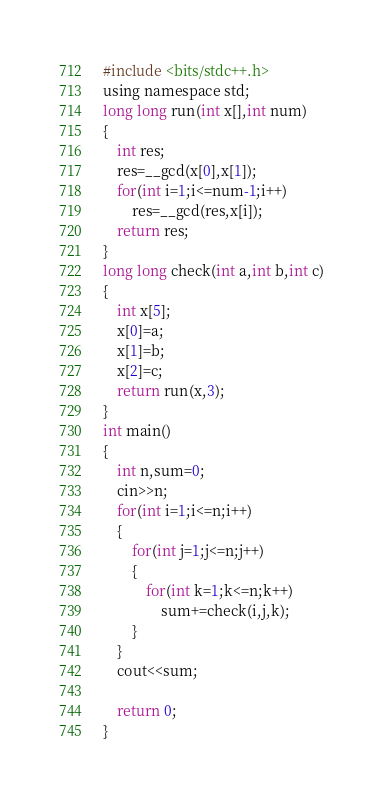Convert code to text. <code><loc_0><loc_0><loc_500><loc_500><_C_>#include <bits/stdc++.h>
using namespace std;
long long run(int x[],int num)
{
	int res;
	res=__gcd(x[0],x[1]);
	for(int i=1;i<=num-1;i++)
		res=__gcd(res,x[i]);
	return res;
}
long long check(int a,int b,int c)
{
	int x[5];
	x[0]=a;
	x[1]=b;
	x[2]=c;
	return run(x,3);
}
int main()
{
	int n,sum=0;
	cin>>n;
	for(int i=1;i<=n;i++)
	{
		for(int j=1;j<=n;j++)
		{
			for(int k=1;k<=n;k++)
				sum+=check(i,j,k);
		}
	}
	cout<<sum;

	return 0;
}</code> 